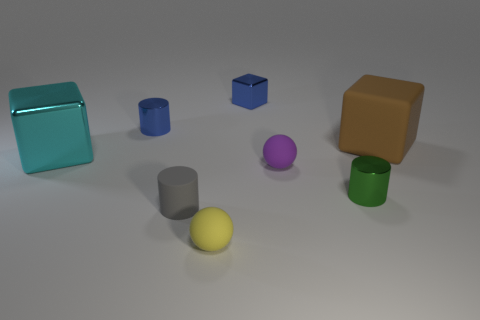How many objects are there in total, and how would you describe their arrangement? In total, there are seven objects arranged randomly on a flat surface. The setup includes a variety of geometric shapes and colors, creating a visually balanced composition. 